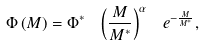<formula> <loc_0><loc_0><loc_500><loc_500>\Phi \left ( M \right ) = \Phi ^ { \ast } \ \left ( \frac { M } { M ^ { \ast } } \right ) ^ { \alpha } \ e ^ { - \frac { M } { M ^ { \ast } } } ,</formula> 